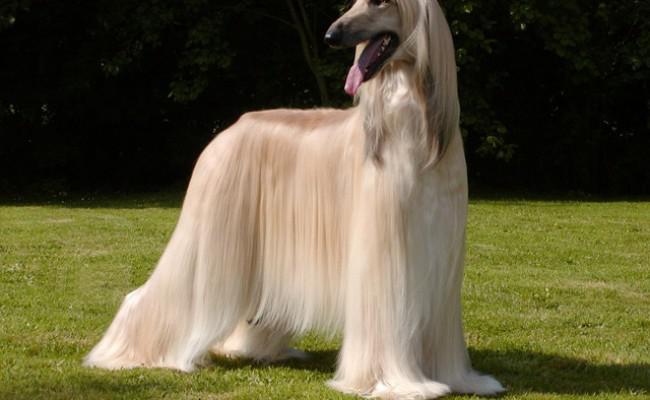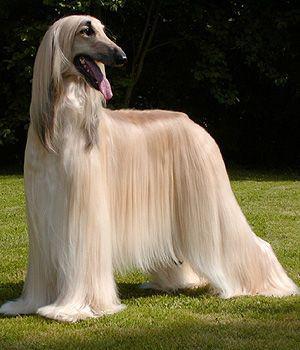The first image is the image on the left, the second image is the image on the right. Evaluate the accuracy of this statement regarding the images: "At least one dog has black fur.". Is it true? Answer yes or no. No. The first image is the image on the left, the second image is the image on the right. Analyze the images presented: Is the assertion "there is one dog lying down in the image on the left" valid? Answer yes or no. No. 